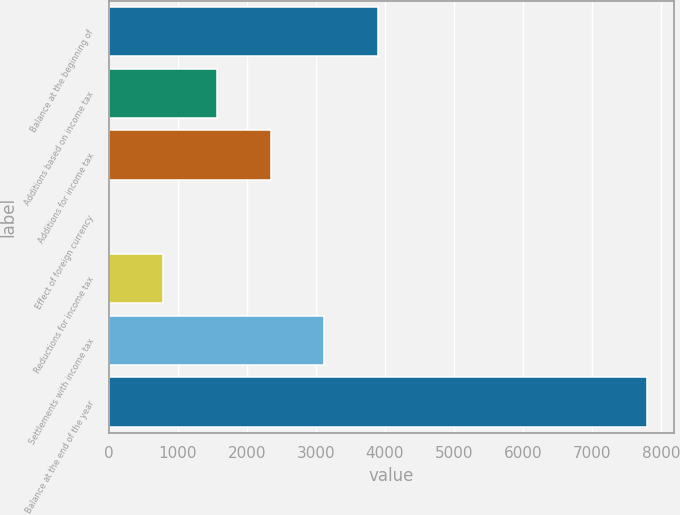Convert chart. <chart><loc_0><loc_0><loc_500><loc_500><bar_chart><fcel>Balance at the beginning of<fcel>Additions based on income tax<fcel>Additions for income tax<fcel>Effect of foreign currency<fcel>Reductions for income tax<fcel>Settlements with income tax<fcel>Balance at the end of the year<nl><fcel>3902.5<fcel>1562.2<fcel>2342.3<fcel>2<fcel>782.1<fcel>3122.4<fcel>7803<nl></chart> 